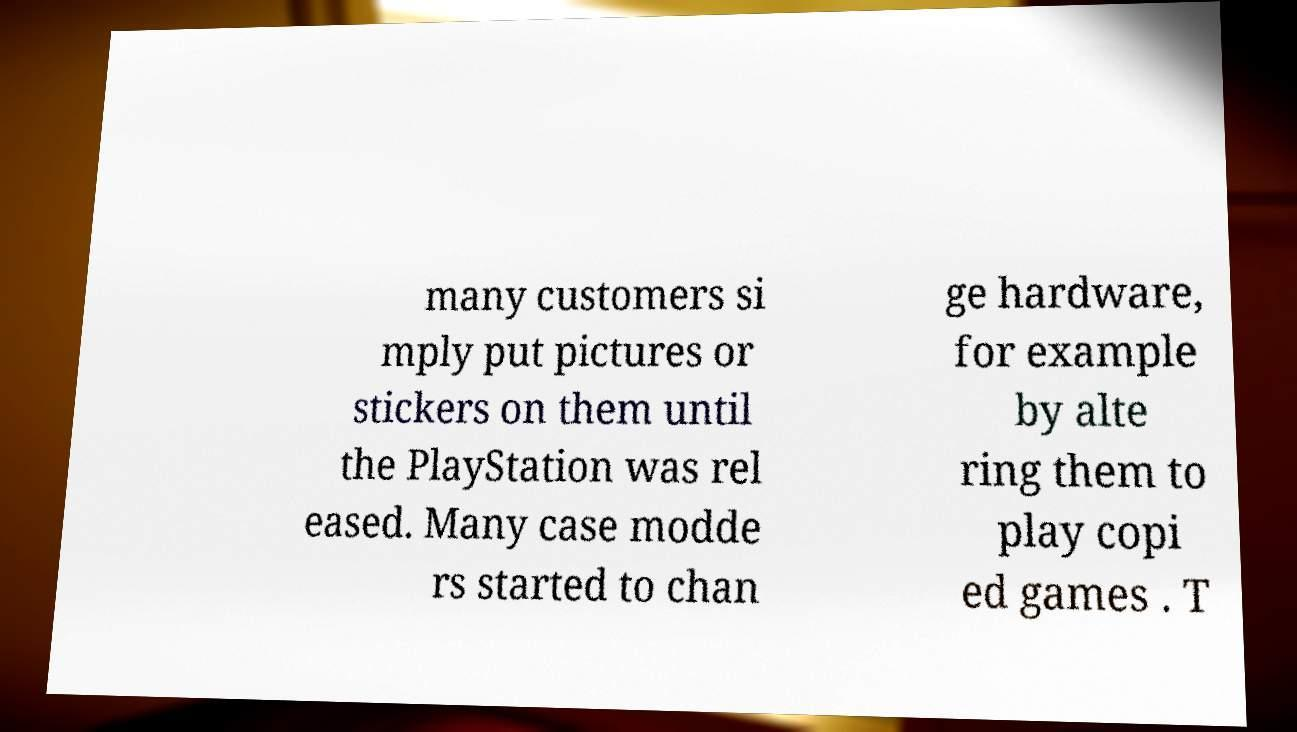Please read and relay the text visible in this image. What does it say? many customers si mply put pictures or stickers on them until the PlayStation was rel eased. Many case modde rs started to chan ge hardware, for example by alte ring them to play copi ed games . T 